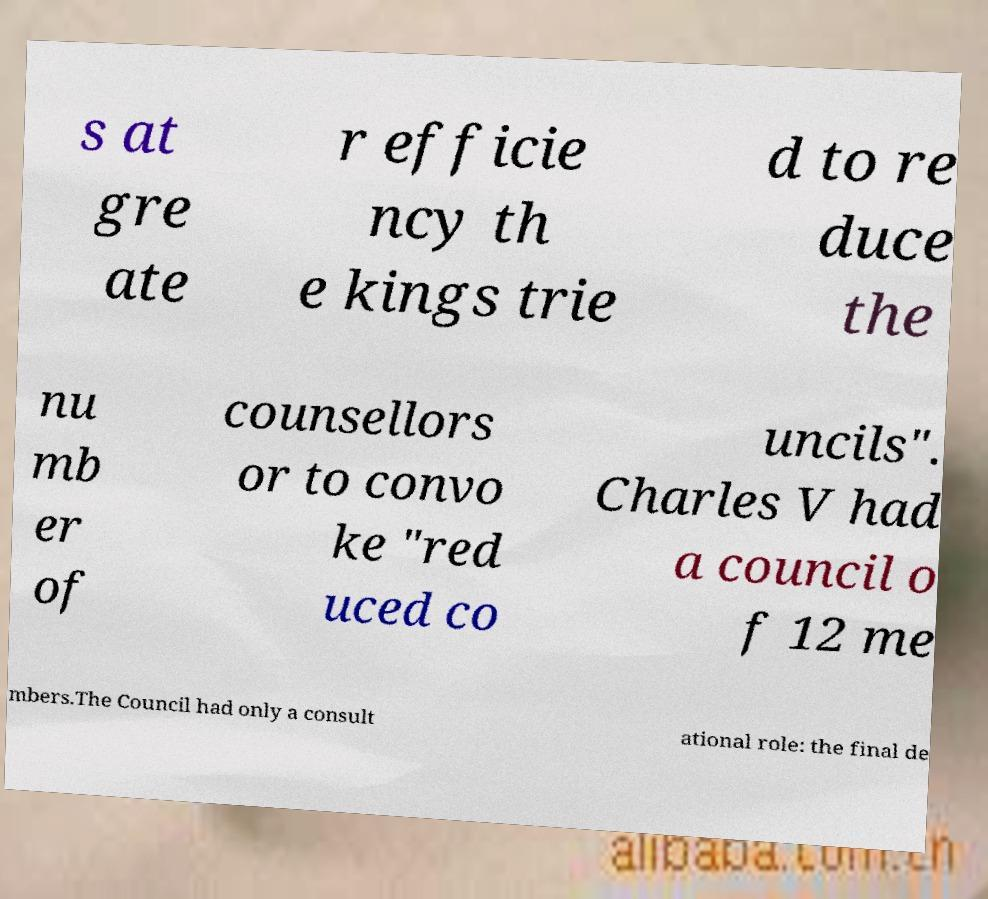Please read and relay the text visible in this image. What does it say? s at gre ate r efficie ncy th e kings trie d to re duce the nu mb er of counsellors or to convo ke "red uced co uncils". Charles V had a council o f 12 me mbers.The Council had only a consult ational role: the final de 